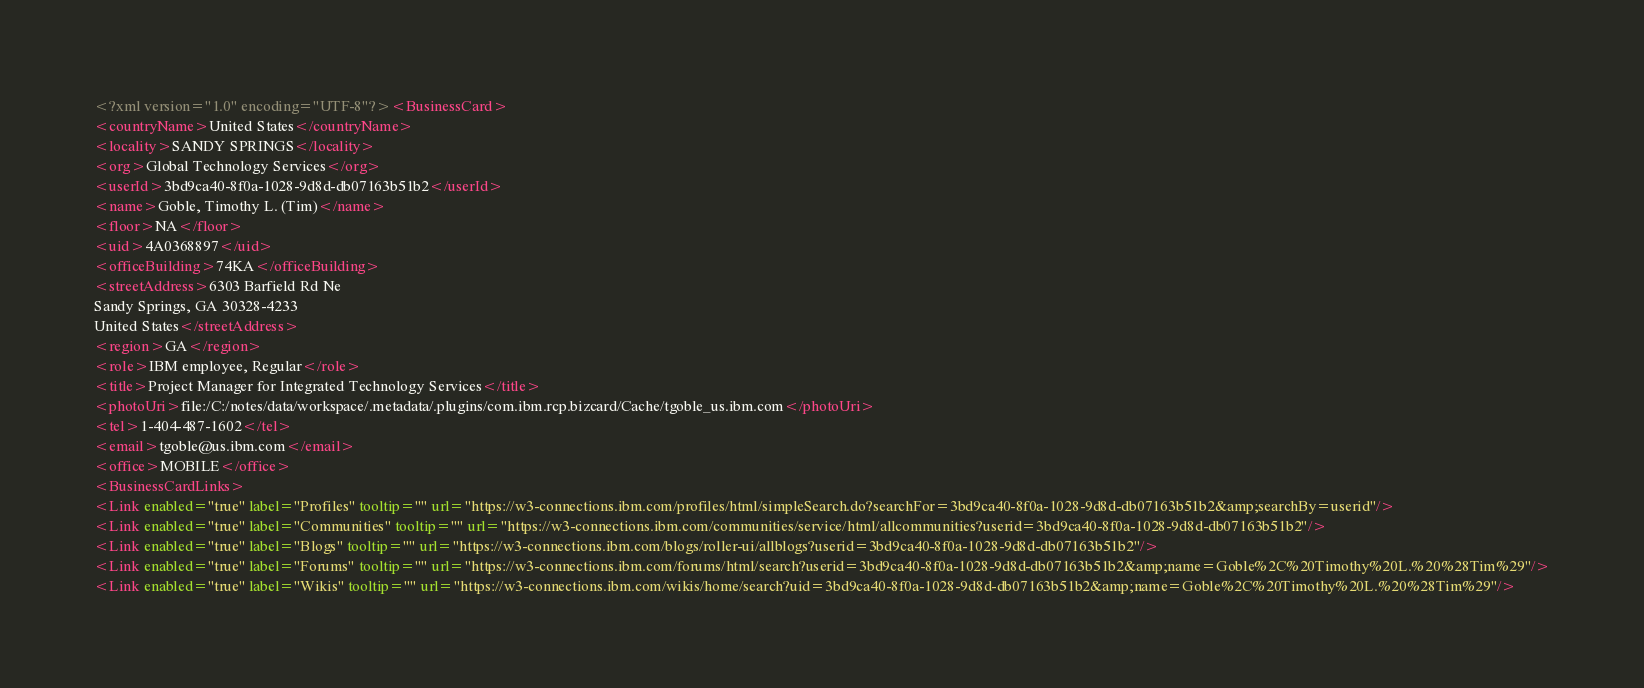<code> <loc_0><loc_0><loc_500><loc_500><_XML_><?xml version="1.0" encoding="UTF-8"?><BusinessCard>
<countryName>United States</countryName>
<locality>SANDY SPRINGS</locality>
<org>Global Technology Services</org>
<userId>3bd9ca40-8f0a-1028-9d8d-db07163b51b2</userId>
<name>Goble, Timothy L. (Tim)</name>
<floor>NA</floor>
<uid>4A0368897</uid>
<officeBuilding>74KA</officeBuilding>
<streetAddress>6303 Barfield Rd Ne
Sandy Springs, GA 30328-4233
United States</streetAddress>
<region>GA</region>
<role>IBM employee, Regular</role>
<title>Project Manager for Integrated Technology Services</title>
<photoUri>file:/C:/notes/data/workspace/.metadata/.plugins/com.ibm.rcp.bizcard/Cache/tgoble_us.ibm.com</photoUri>
<tel>1-404-487-1602</tel>
<email>tgoble@us.ibm.com</email>
<office>MOBILE</office>
<BusinessCardLinks>
<Link enabled="true" label="Profiles" tooltip="" url="https://w3-connections.ibm.com/profiles/html/simpleSearch.do?searchFor=3bd9ca40-8f0a-1028-9d8d-db07163b51b2&amp;searchBy=userid"/>
<Link enabled="true" label="Communities" tooltip="" url="https://w3-connections.ibm.com/communities/service/html/allcommunities?userid=3bd9ca40-8f0a-1028-9d8d-db07163b51b2"/>
<Link enabled="true" label="Blogs" tooltip="" url="https://w3-connections.ibm.com/blogs/roller-ui/allblogs?userid=3bd9ca40-8f0a-1028-9d8d-db07163b51b2"/>
<Link enabled="true" label="Forums" tooltip="" url="https://w3-connections.ibm.com/forums/html/search?userid=3bd9ca40-8f0a-1028-9d8d-db07163b51b2&amp;name=Goble%2C%20Timothy%20L.%20%28Tim%29"/>
<Link enabled="true" label="Wikis" tooltip="" url="https://w3-connections.ibm.com/wikis/home/search?uid=3bd9ca40-8f0a-1028-9d8d-db07163b51b2&amp;name=Goble%2C%20Timothy%20L.%20%28Tim%29"/></code> 